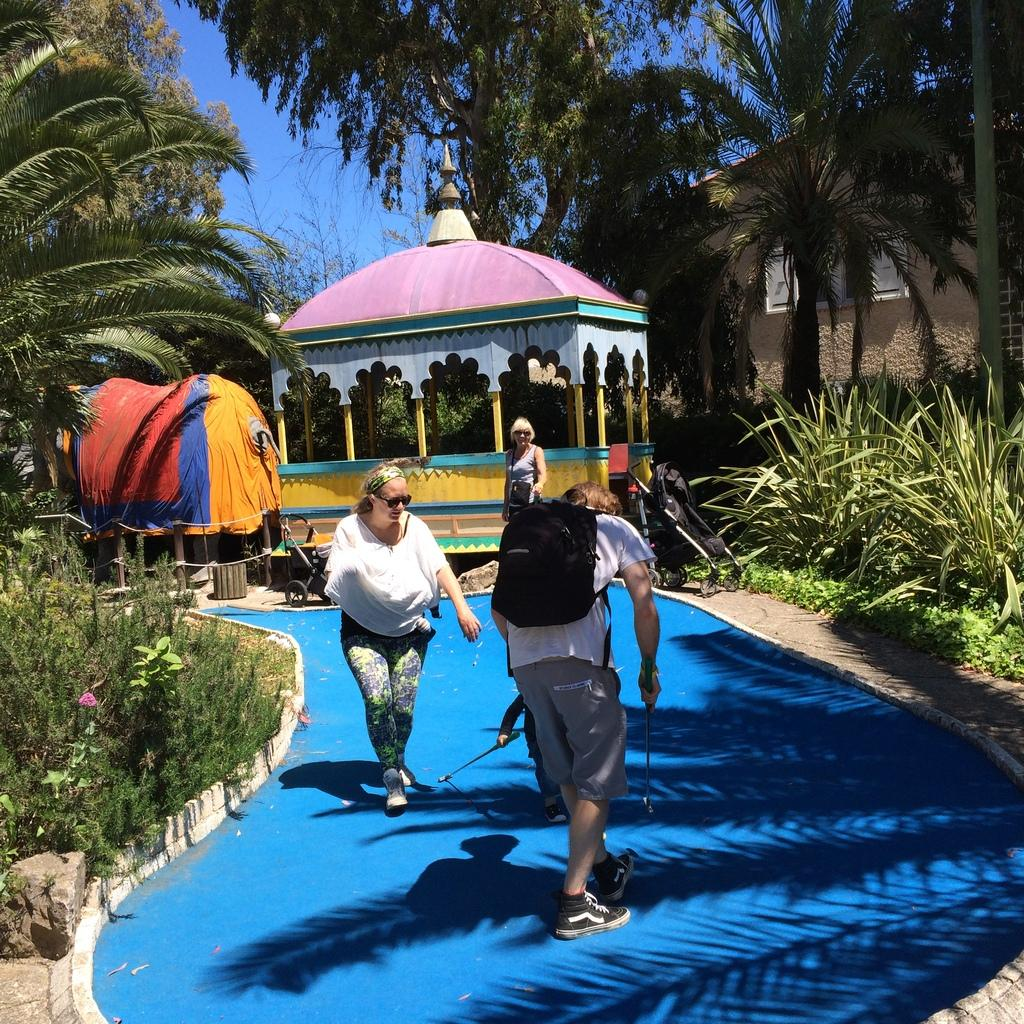How many people can be seen in the image? There are people in the image, but the exact number is not specified. What are the two people carrying? The two people are carrying bags. What type of vegetation is present in the image? There are trees and plants in the image. What type of toy can be seen in the image? There is a toy train in the image. What type of structure is visible in the image? There is a house in the image. What is visible in the background of the image? The sky is visible in the background of the image. Where is the queen sitting in the image? There is no queen present in the image. What type of books can be seen on the edge of the table in the image? There are no books visible in the image. 